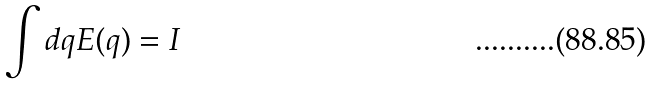Convert formula to latex. <formula><loc_0><loc_0><loc_500><loc_500>\int d q E ( q ) = I</formula> 